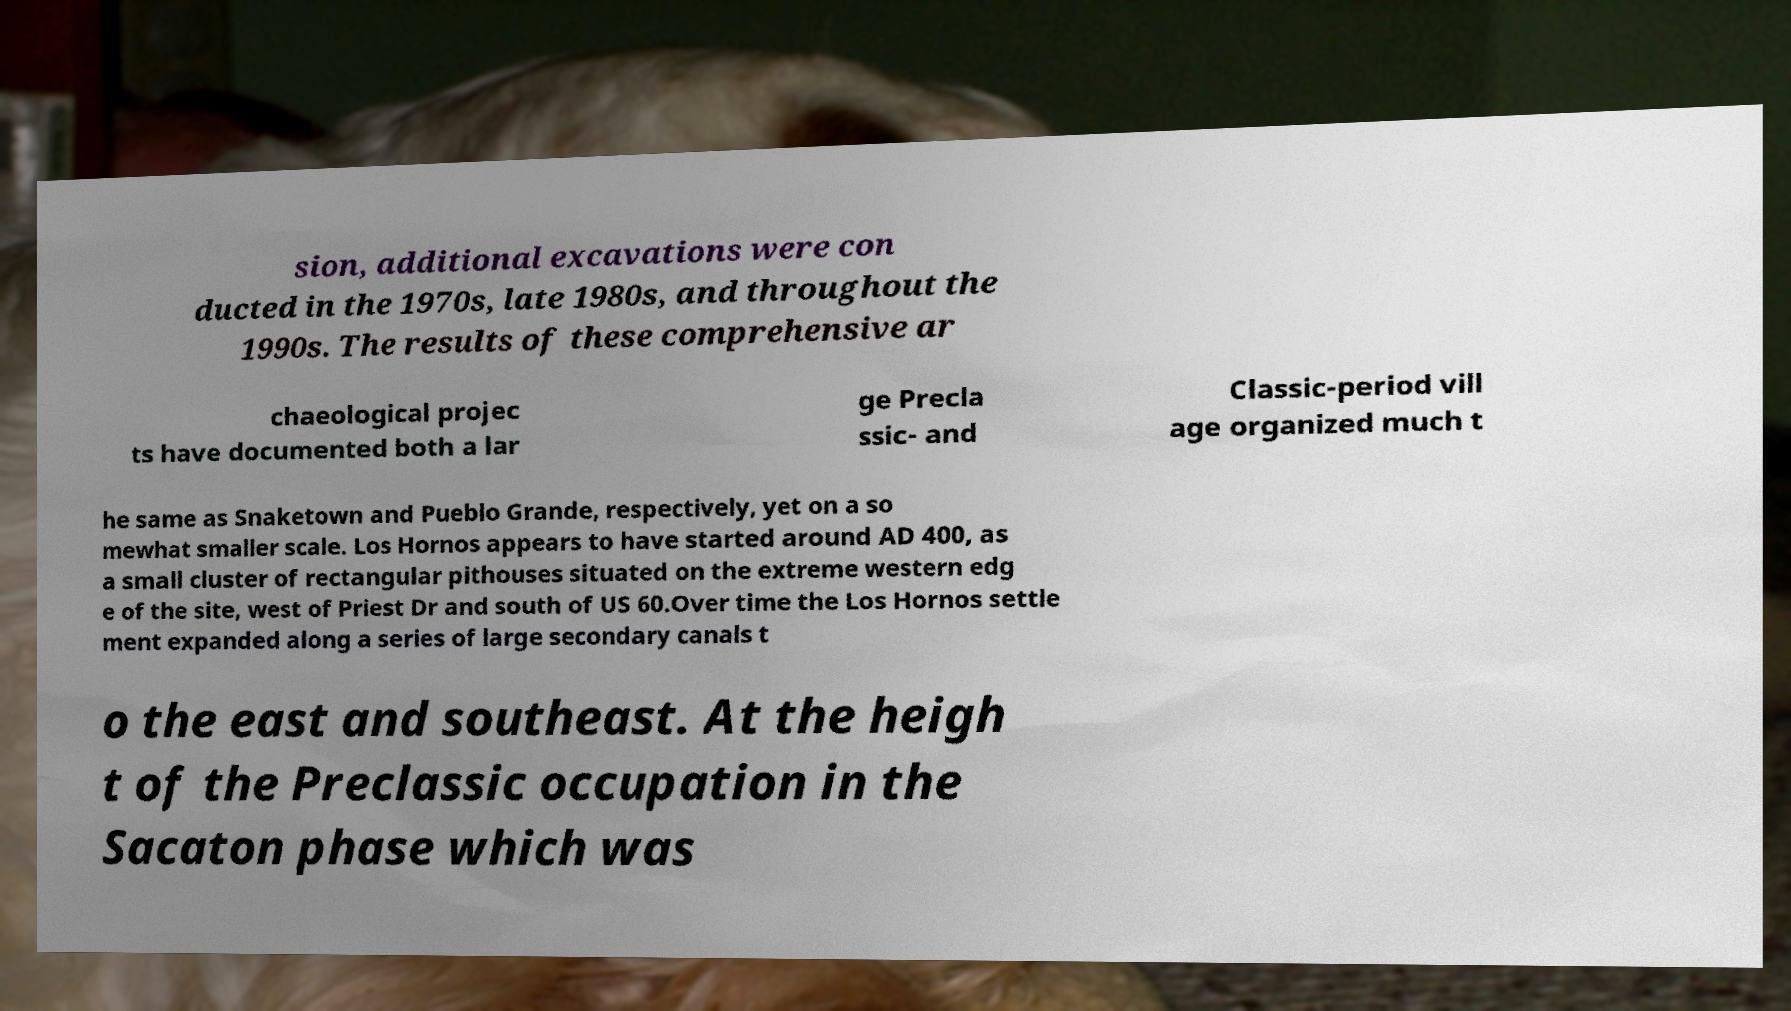Please identify and transcribe the text found in this image. sion, additional excavations were con ducted in the 1970s, late 1980s, and throughout the 1990s. The results of these comprehensive ar chaeological projec ts have documented both a lar ge Precla ssic- and Classic-period vill age organized much t he same as Snaketown and Pueblo Grande, respectively, yet on a so mewhat smaller scale. Los Hornos appears to have started around AD 400, as a small cluster of rectangular pithouses situated on the extreme western edg e of the site, west of Priest Dr and south of US 60.Over time the Los Hornos settle ment expanded along a series of large secondary canals t o the east and southeast. At the heigh t of the Preclassic occupation in the Sacaton phase which was 